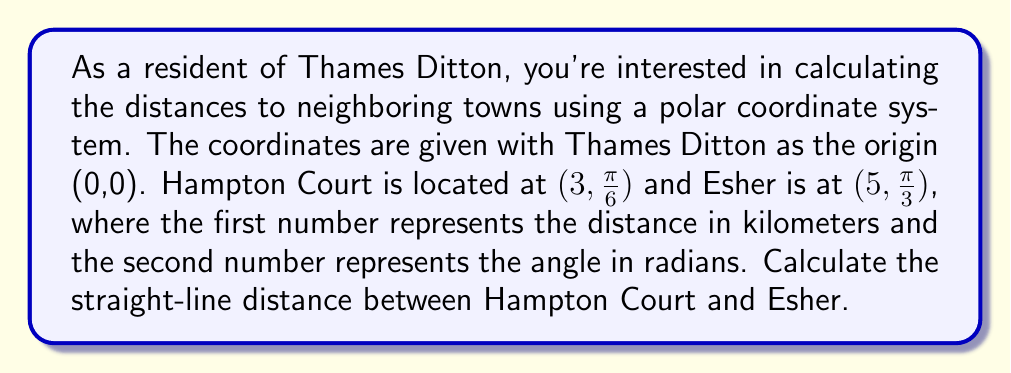Give your solution to this math problem. To solve this problem, we'll use the following steps:

1) First, let's recall the formula for finding the distance between two points in polar coordinates:

   $$d = \sqrt{r_1^2 + r_2^2 - 2r_1r_2\cos(\theta_2 - \theta_1)}$$

   Where $(r_1, \theta_1)$ and $(r_2, \theta_2)$ are the polar coordinates of the two points.

2) We have:
   Hampton Court: $(r_1, \theta_1) = (3, \frac{\pi}{6})$
   Esher: $(r_2, \theta_2) = (5, \frac{\pi}{3})$

3) Let's substitute these values into our formula:

   $$d = \sqrt{3^2 + 5^2 - 2(3)(5)\cos(\frac{\pi}{3} - \frac{\pi}{6})}$$

4) Simplify inside the parentheses:

   $$d = \sqrt{3^2 + 5^2 - 2(3)(5)\cos(\frac{\pi}{6})}$$

5) Calculate the squares and multiply:

   $$d = \sqrt{9 + 25 - 30\cos(\frac{\pi}{6})}$$

6) Recall that $\cos(\frac{\pi}{6}) = \frac{\sqrt{3}}{2}$:

   $$d = \sqrt{34 - 30(\frac{\sqrt{3}}{2})}$$

7) Simplify:

   $$d = \sqrt{34 - 15\sqrt{3}}$$

This is our final answer in exact form. If we want a decimal approximation:

8) Calculate:

   $$d \approx 3.84$$ km (rounded to two decimal places)

[asy]
import geometry;

unitsize(30);
draw(circle((0,0),5));
draw((0,0)--(3,sqrt(3)),Arrow);
draw((0,0)--(2.5,4.33),Arrow);
dot((0,0));
label("Thames Ditton (0,0)", (0,-0.5), S);
dot((3,sqrt(3)));
label("Hampton Court", (3,sqrt(3)), NE);
dot((2.5,4.33));
label("Esher", (2.5,4.33), N);
draw((3,sqrt(3))--(2.5,4.33),dashed);
[/asy]
Answer: The straight-line distance between Hampton Court and Esher is $\sqrt{34 - 15\sqrt{3}}$ km, or approximately 3.84 km. 